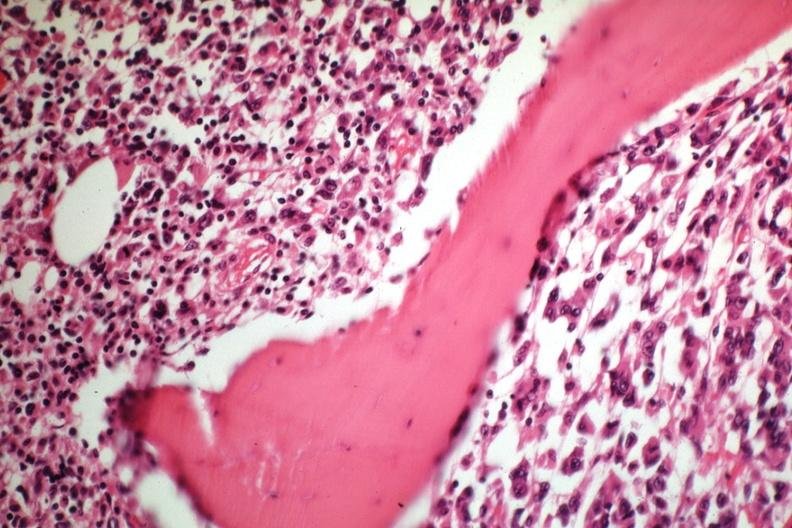does this image show tumor well shown gross is slide?
Answer the question using a single word or phrase. Yes 